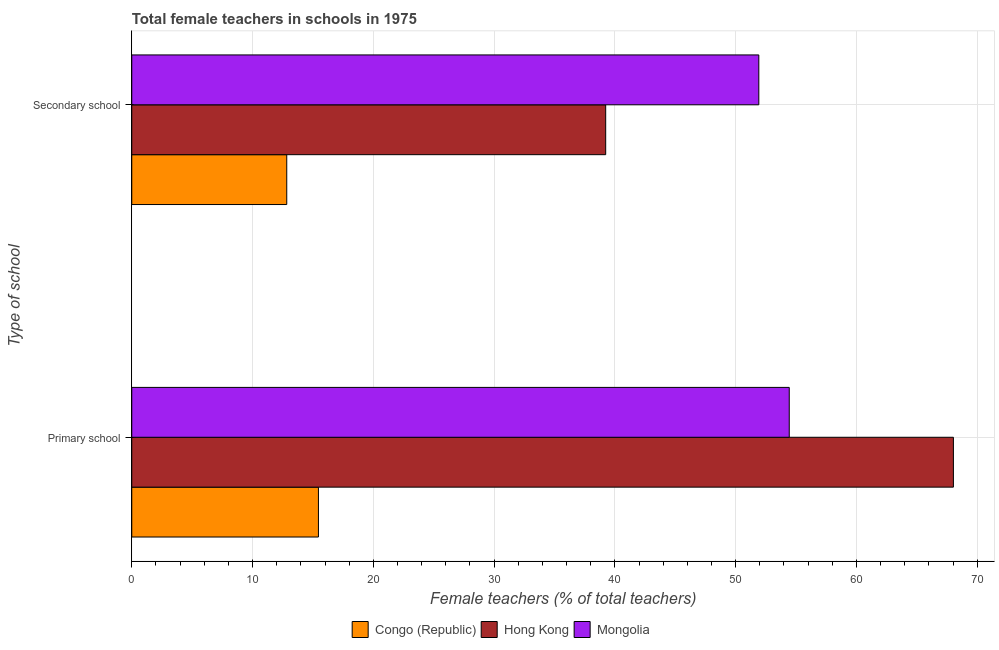Are the number of bars on each tick of the Y-axis equal?
Your answer should be very brief. Yes. How many bars are there on the 2nd tick from the bottom?
Your response must be concise. 3. What is the label of the 1st group of bars from the top?
Provide a succinct answer. Secondary school. What is the percentage of female teachers in secondary schools in Mongolia?
Ensure brevity in your answer.  51.92. Across all countries, what is the maximum percentage of female teachers in primary schools?
Provide a succinct answer. 68.03. Across all countries, what is the minimum percentage of female teachers in primary schools?
Keep it short and to the point. 15.46. In which country was the percentage of female teachers in primary schools maximum?
Make the answer very short. Hong Kong. In which country was the percentage of female teachers in primary schools minimum?
Provide a succinct answer. Congo (Republic). What is the total percentage of female teachers in primary schools in the graph?
Ensure brevity in your answer.  137.93. What is the difference between the percentage of female teachers in primary schools in Mongolia and that in Congo (Republic)?
Ensure brevity in your answer.  38.98. What is the difference between the percentage of female teachers in primary schools in Mongolia and the percentage of female teachers in secondary schools in Hong Kong?
Keep it short and to the point. 15.2. What is the average percentage of female teachers in primary schools per country?
Make the answer very short. 45.98. What is the difference between the percentage of female teachers in primary schools and percentage of female teachers in secondary schools in Mongolia?
Your response must be concise. 2.52. In how many countries, is the percentage of female teachers in secondary schools greater than 30 %?
Offer a very short reply. 2. What is the ratio of the percentage of female teachers in secondary schools in Congo (Republic) to that in Hong Kong?
Give a very brief answer. 0.33. In how many countries, is the percentage of female teachers in primary schools greater than the average percentage of female teachers in primary schools taken over all countries?
Offer a very short reply. 2. What does the 3rd bar from the top in Secondary school represents?
Your answer should be very brief. Congo (Republic). What does the 3rd bar from the bottom in Primary school represents?
Provide a short and direct response. Mongolia. How many bars are there?
Your answer should be compact. 6. Are the values on the major ticks of X-axis written in scientific E-notation?
Provide a succinct answer. No. Does the graph contain any zero values?
Your answer should be compact. No. Where does the legend appear in the graph?
Give a very brief answer. Bottom center. How are the legend labels stacked?
Provide a short and direct response. Horizontal. What is the title of the graph?
Your answer should be very brief. Total female teachers in schools in 1975. What is the label or title of the X-axis?
Your response must be concise. Female teachers (% of total teachers). What is the label or title of the Y-axis?
Offer a terse response. Type of school. What is the Female teachers (% of total teachers) in Congo (Republic) in Primary school?
Provide a short and direct response. 15.46. What is the Female teachers (% of total teachers) of Hong Kong in Primary school?
Provide a short and direct response. 68.03. What is the Female teachers (% of total teachers) of Mongolia in Primary school?
Make the answer very short. 54.44. What is the Female teachers (% of total teachers) in Congo (Republic) in Secondary school?
Your response must be concise. 12.83. What is the Female teachers (% of total teachers) in Hong Kong in Secondary school?
Ensure brevity in your answer.  39.24. What is the Female teachers (% of total teachers) in Mongolia in Secondary school?
Ensure brevity in your answer.  51.92. Across all Type of school, what is the maximum Female teachers (% of total teachers) in Congo (Republic)?
Ensure brevity in your answer.  15.46. Across all Type of school, what is the maximum Female teachers (% of total teachers) in Hong Kong?
Provide a short and direct response. 68.03. Across all Type of school, what is the maximum Female teachers (% of total teachers) in Mongolia?
Offer a terse response. 54.44. Across all Type of school, what is the minimum Female teachers (% of total teachers) of Congo (Republic)?
Keep it short and to the point. 12.83. Across all Type of school, what is the minimum Female teachers (% of total teachers) of Hong Kong?
Offer a very short reply. 39.24. Across all Type of school, what is the minimum Female teachers (% of total teachers) of Mongolia?
Provide a short and direct response. 51.92. What is the total Female teachers (% of total teachers) in Congo (Republic) in the graph?
Your response must be concise. 28.29. What is the total Female teachers (% of total teachers) in Hong Kong in the graph?
Offer a terse response. 107.27. What is the total Female teachers (% of total teachers) in Mongolia in the graph?
Your answer should be very brief. 106.36. What is the difference between the Female teachers (% of total teachers) in Congo (Republic) in Primary school and that in Secondary school?
Ensure brevity in your answer.  2.62. What is the difference between the Female teachers (% of total teachers) of Hong Kong in Primary school and that in Secondary school?
Your answer should be compact. 28.79. What is the difference between the Female teachers (% of total teachers) of Mongolia in Primary school and that in Secondary school?
Provide a succinct answer. 2.52. What is the difference between the Female teachers (% of total teachers) of Congo (Republic) in Primary school and the Female teachers (% of total teachers) of Hong Kong in Secondary school?
Make the answer very short. -23.79. What is the difference between the Female teachers (% of total teachers) of Congo (Republic) in Primary school and the Female teachers (% of total teachers) of Mongolia in Secondary school?
Your answer should be very brief. -36.46. What is the difference between the Female teachers (% of total teachers) in Hong Kong in Primary school and the Female teachers (% of total teachers) in Mongolia in Secondary school?
Your response must be concise. 16.11. What is the average Female teachers (% of total teachers) of Congo (Republic) per Type of school?
Your answer should be very brief. 14.14. What is the average Female teachers (% of total teachers) of Hong Kong per Type of school?
Offer a terse response. 53.64. What is the average Female teachers (% of total teachers) of Mongolia per Type of school?
Your answer should be very brief. 53.18. What is the difference between the Female teachers (% of total teachers) in Congo (Republic) and Female teachers (% of total teachers) in Hong Kong in Primary school?
Your answer should be very brief. -52.58. What is the difference between the Female teachers (% of total teachers) in Congo (Republic) and Female teachers (% of total teachers) in Mongolia in Primary school?
Your answer should be compact. -38.98. What is the difference between the Female teachers (% of total teachers) in Hong Kong and Female teachers (% of total teachers) in Mongolia in Primary school?
Provide a succinct answer. 13.59. What is the difference between the Female teachers (% of total teachers) in Congo (Republic) and Female teachers (% of total teachers) in Hong Kong in Secondary school?
Give a very brief answer. -26.41. What is the difference between the Female teachers (% of total teachers) in Congo (Republic) and Female teachers (% of total teachers) in Mongolia in Secondary school?
Keep it short and to the point. -39.09. What is the difference between the Female teachers (% of total teachers) of Hong Kong and Female teachers (% of total teachers) of Mongolia in Secondary school?
Ensure brevity in your answer.  -12.68. What is the ratio of the Female teachers (% of total teachers) in Congo (Republic) in Primary school to that in Secondary school?
Ensure brevity in your answer.  1.2. What is the ratio of the Female teachers (% of total teachers) in Hong Kong in Primary school to that in Secondary school?
Give a very brief answer. 1.73. What is the ratio of the Female teachers (% of total teachers) in Mongolia in Primary school to that in Secondary school?
Offer a very short reply. 1.05. What is the difference between the highest and the second highest Female teachers (% of total teachers) in Congo (Republic)?
Your answer should be very brief. 2.62. What is the difference between the highest and the second highest Female teachers (% of total teachers) of Hong Kong?
Give a very brief answer. 28.79. What is the difference between the highest and the second highest Female teachers (% of total teachers) in Mongolia?
Offer a very short reply. 2.52. What is the difference between the highest and the lowest Female teachers (% of total teachers) of Congo (Republic)?
Your answer should be compact. 2.62. What is the difference between the highest and the lowest Female teachers (% of total teachers) in Hong Kong?
Offer a terse response. 28.79. What is the difference between the highest and the lowest Female teachers (% of total teachers) of Mongolia?
Offer a terse response. 2.52. 